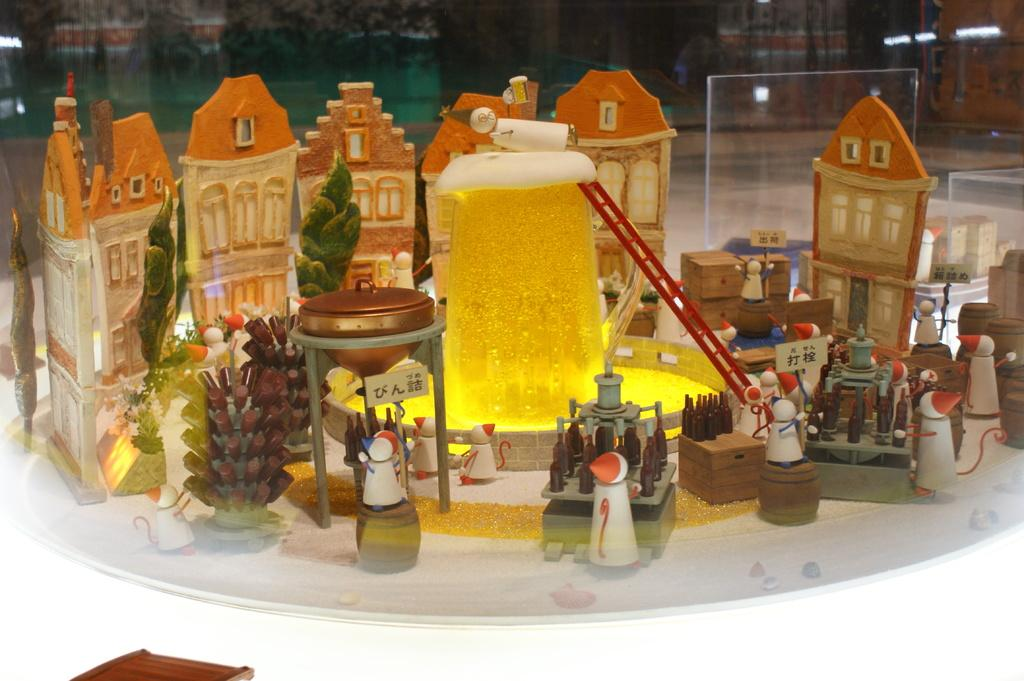What type of image is being described? The image is a photograph. What is the main focus of the photograph? There are buildings in the center of the image. Can you describe the buildings in the photograph? The architecture of the buildings is visible. What can be seen in the background of the photograph? There is a wall and lights in the background of the image. How many ladybugs are crawling on the buildings in the image? There are no ladybugs present in the image. What historical event is depicted in the photograph? The photograph does not depict any historical event; it simply shows buildings and their architecture. 